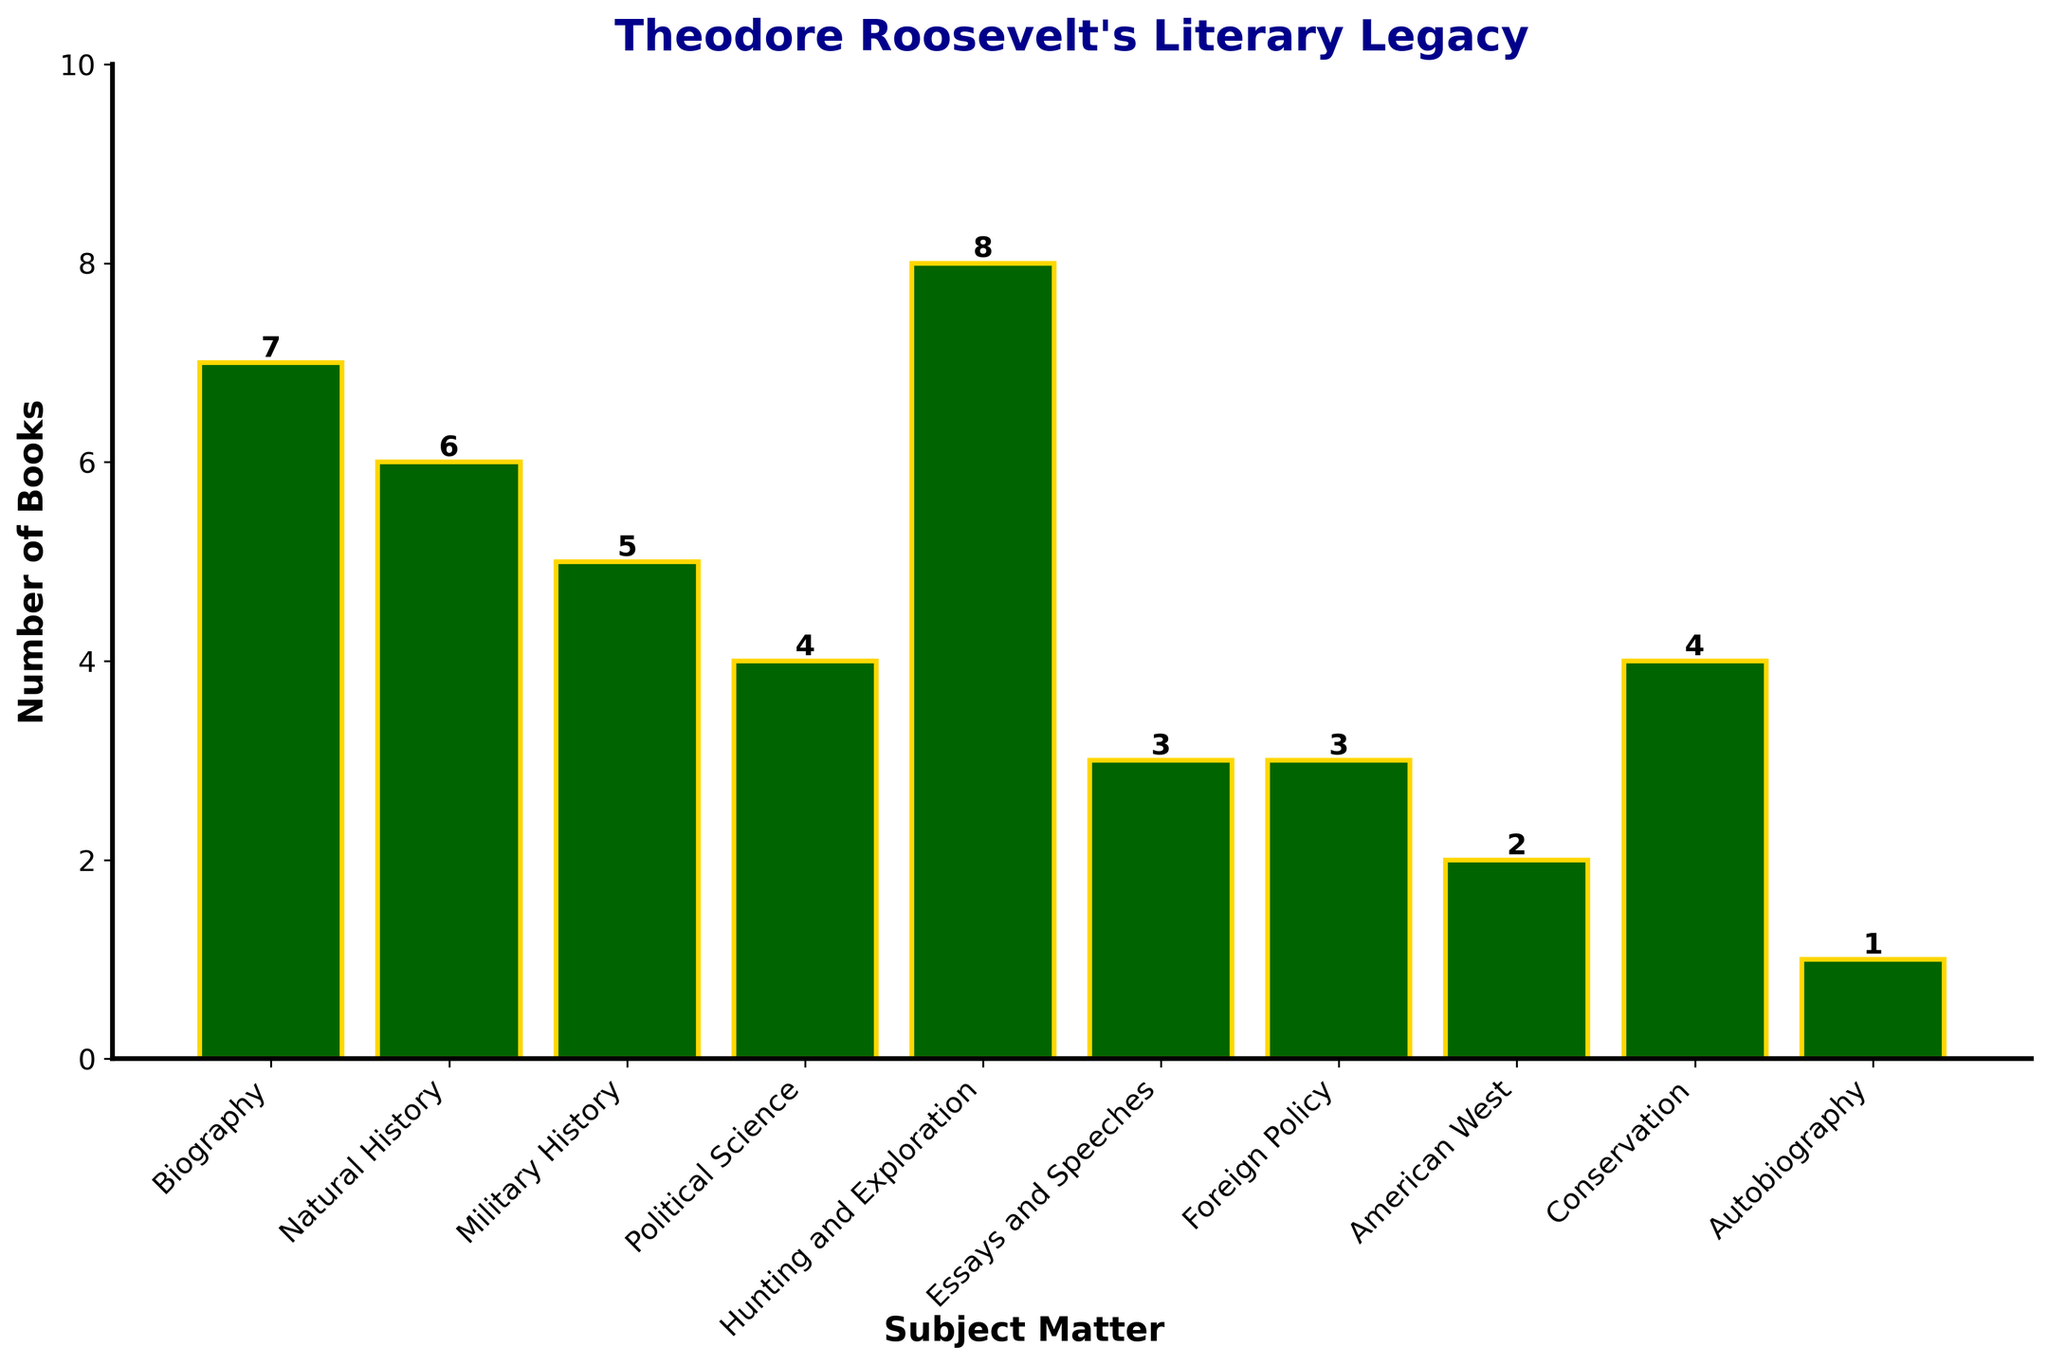Which subject has the highest number of books authored by Theodore Roosevelt? The bar for "Hunting and Exploration" is the tallest in the chart, indicating the highest number of books.
Answer: Hunting and Exploration Which two subjects are tied for the lowest number of books? The bars for "Autobiography" and "American West" are the shortest, both having the same height indicating they are equal.
Answer: Autobiography and American West How many more books did Roosevelt write on "Hunting and Exploration" compared to "Natural History"? The bar height for "Hunting and Exploration" is 8 and for "Natural History" is 6. Subtracting 6 from 8 gives 2 more books.
Answer: 2 What is the total number of books written on "Biography" and "Political Science"? The bar height for "Biography" is 7 and for "Political Science" is 4. Adding 7 and 4 gives a total of 11 books.
Answer: 11 Which subject has twice as many books as "Autobiography"? The bar height for "Autobiography" is 1. The bar for "American West" is 2, which is twice the number of books in "Autobiography".
Answer: American West What is the average number of books written across all the subjects? Sum the number of books across all subjects (7+6+5+4+8+3+3+2+4+1 = 43), then divide by the number of subjects (10). The average is 43/10.
Answer: 4.3 How many subjects have more than 4 books written on them? "Biography," "Natural History," "Military History," and "Hunting and Exploration" bars are all above 4. Count these subjects, which gives 4.
Answer: 4 Which categories have an equal number of books written on them? The bars for "Essays and Speeches" and "Foreign Policy" are at the same height, each with 3 books.
Answer: Essays and Speeches and Foreign Policy 